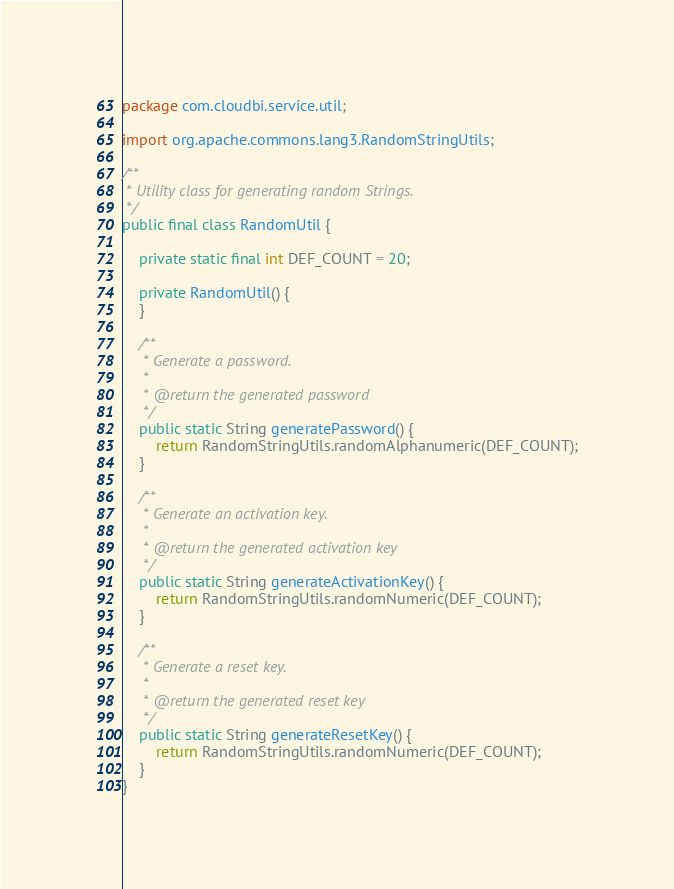Convert code to text. <code><loc_0><loc_0><loc_500><loc_500><_Java_>package com.cloudbi.service.util;

import org.apache.commons.lang3.RandomStringUtils;

/**
 * Utility class for generating random Strings.
 */
public final class RandomUtil {

    private static final int DEF_COUNT = 20;

    private RandomUtil() {
    }

    /**
     * Generate a password.
     *
     * @return the generated password
     */
    public static String generatePassword() {
        return RandomStringUtils.randomAlphanumeric(DEF_COUNT);
    }

    /**
     * Generate an activation key.
     *
     * @return the generated activation key
     */
    public static String generateActivationKey() {
        return RandomStringUtils.randomNumeric(DEF_COUNT);
    }

    /**
     * Generate a reset key.
     *
     * @return the generated reset key
     */
    public static String generateResetKey() {
        return RandomStringUtils.randomNumeric(DEF_COUNT);
    }
}
</code> 